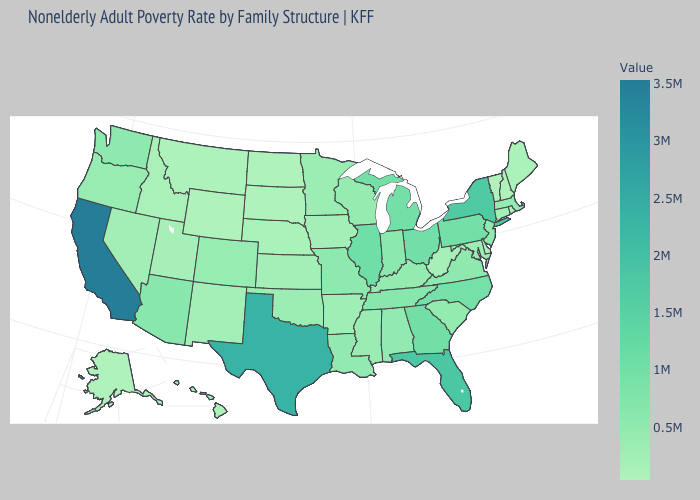Is the legend a continuous bar?
Short answer required. Yes. Does the map have missing data?
Be succinct. No. Does Virginia have a higher value than Vermont?
Concise answer only. Yes. Does Wisconsin have a higher value than Michigan?
Write a very short answer. No. Among the states that border California , does Oregon have the highest value?
Answer briefly. No. Among the states that border Maryland , does Pennsylvania have the highest value?
Give a very brief answer. Yes. 